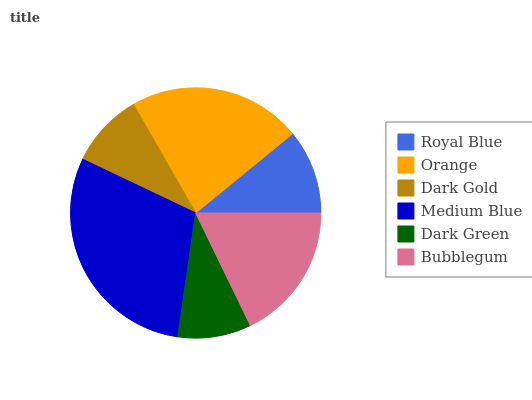Is Dark Green the minimum?
Answer yes or no. Yes. Is Medium Blue the maximum?
Answer yes or no. Yes. Is Orange the minimum?
Answer yes or no. No. Is Orange the maximum?
Answer yes or no. No. Is Orange greater than Royal Blue?
Answer yes or no. Yes. Is Royal Blue less than Orange?
Answer yes or no. Yes. Is Royal Blue greater than Orange?
Answer yes or no. No. Is Orange less than Royal Blue?
Answer yes or no. No. Is Bubblegum the high median?
Answer yes or no. Yes. Is Royal Blue the low median?
Answer yes or no. Yes. Is Medium Blue the high median?
Answer yes or no. No. Is Bubblegum the low median?
Answer yes or no. No. 